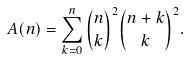<formula> <loc_0><loc_0><loc_500><loc_500>A ( n ) = \sum _ { k = 0 } ^ { n } \binom { n } { k } ^ { 2 } \binom { n + k } { k } ^ { 2 } .</formula> 